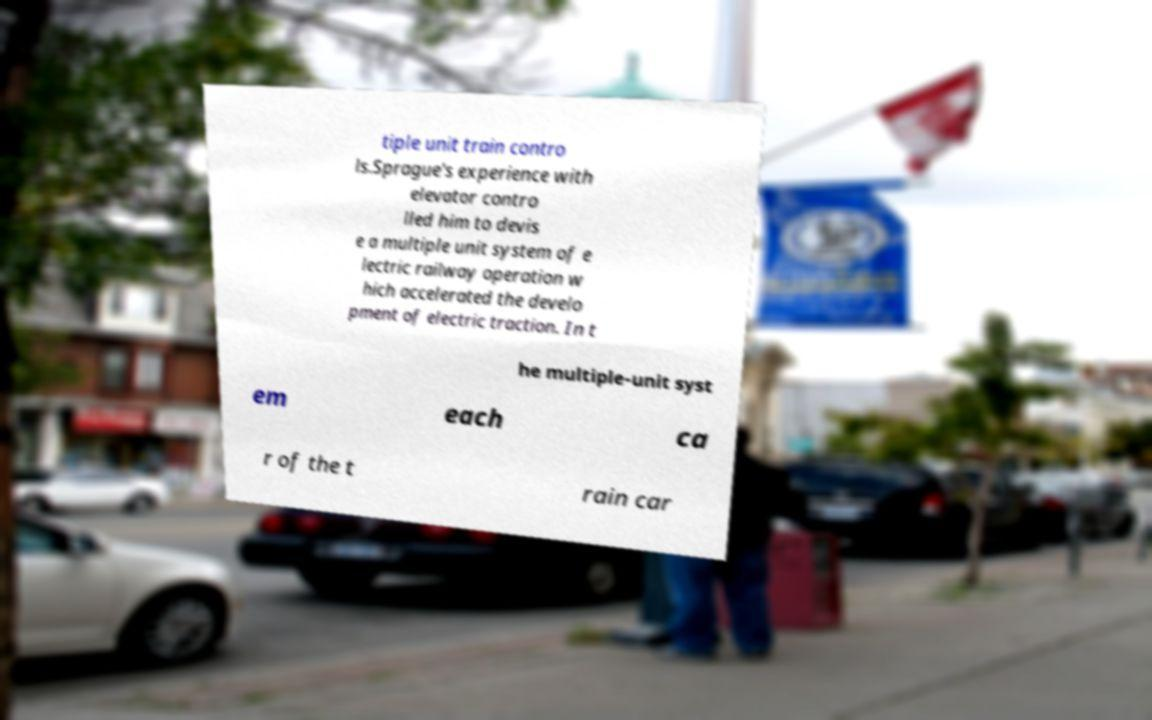Can you accurately transcribe the text from the provided image for me? tiple unit train contro ls.Sprague's experience with elevator contro lled him to devis e a multiple unit system of e lectric railway operation w hich accelerated the develo pment of electric traction. In t he multiple-unit syst em each ca r of the t rain car 